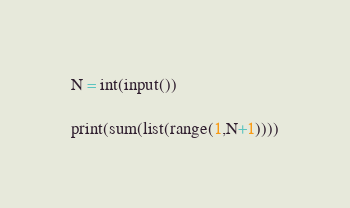<code> <loc_0><loc_0><loc_500><loc_500><_Python_>N = int(input())

print(sum(list(range(1,N+1))))</code> 